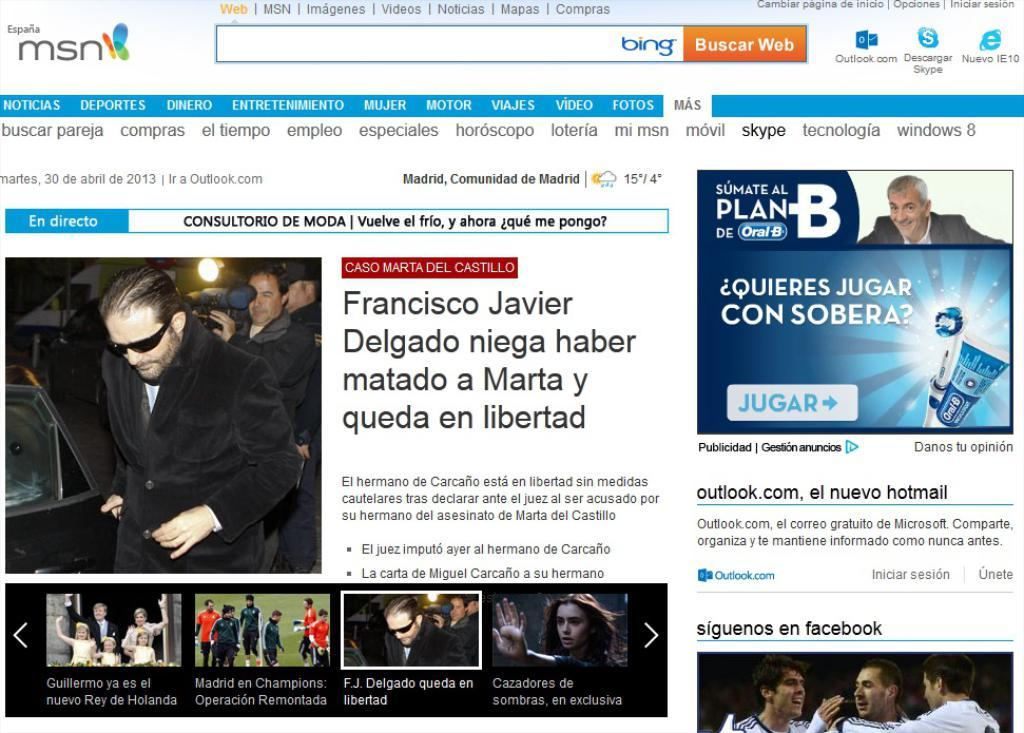What type of image is being described? The image is a screenshot of a website. What can be seen on the website besides text? There are pictures of persons on the website. What information is conveyed through the text on the website? The text on the website provides additional information or context. How many bears can be seen playing in the waves on the website? There are no bears or waves depicted on the website; it features pictures of persons and text. 